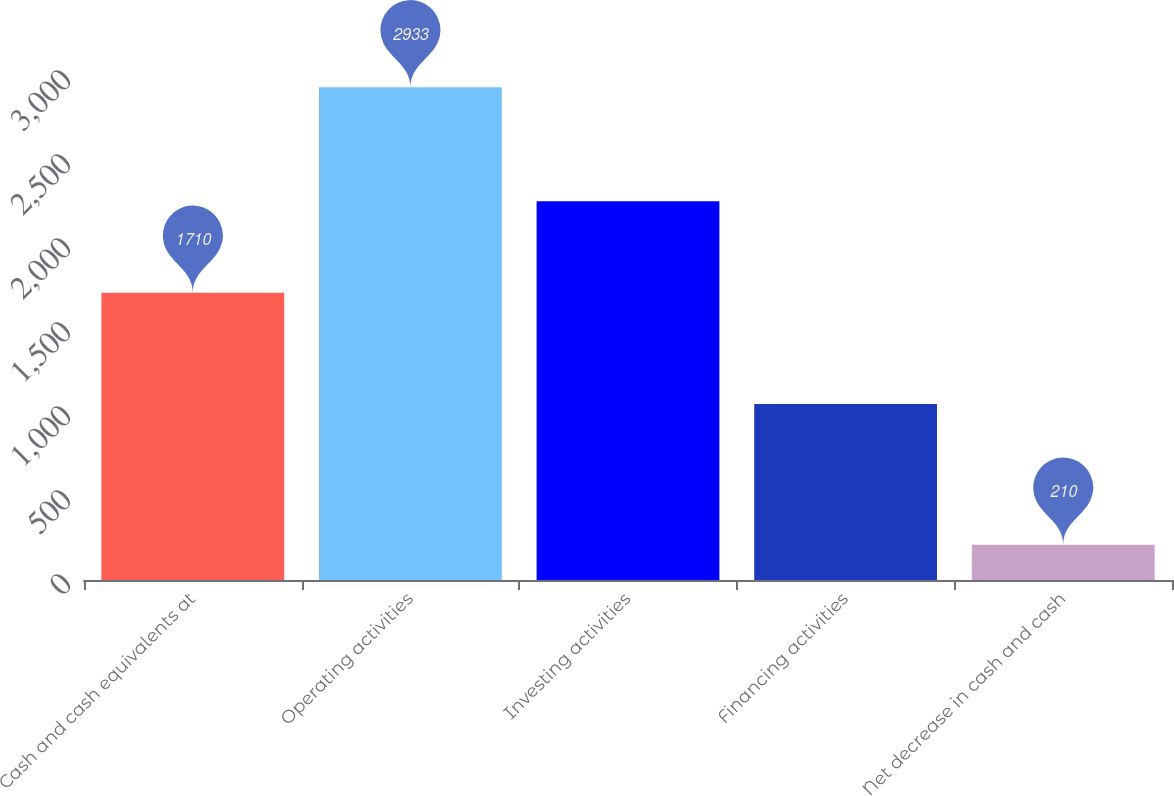<chart> <loc_0><loc_0><loc_500><loc_500><bar_chart><fcel>Cash and cash equivalents at<fcel>Operating activities<fcel>Investing activities<fcel>Financing activities<fcel>Net decrease in cash and cash<nl><fcel>1710<fcel>2933<fcel>2254.6<fcel>1048<fcel>210<nl></chart> 